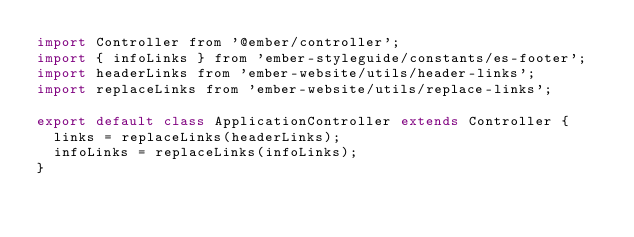Convert code to text. <code><loc_0><loc_0><loc_500><loc_500><_JavaScript_>import Controller from '@ember/controller';
import { infoLinks } from 'ember-styleguide/constants/es-footer';
import headerLinks from 'ember-website/utils/header-links';
import replaceLinks from 'ember-website/utils/replace-links';

export default class ApplicationController extends Controller {
  links = replaceLinks(headerLinks);
  infoLinks = replaceLinks(infoLinks);
}
</code> 